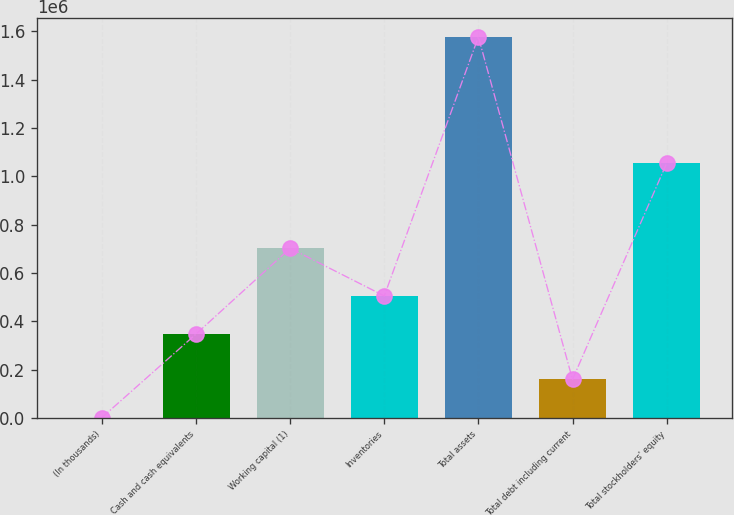<chart> <loc_0><loc_0><loc_500><loc_500><bar_chart><fcel>(In thousands)<fcel>Cash and cash equivalents<fcel>Working capital (1)<fcel>Inventories<fcel>Total assets<fcel>Total debt including current<fcel>Total stockholders' equity<nl><fcel>2013<fcel>347489<fcel>702181<fcel>504925<fcel>1.57637e+06<fcel>159449<fcel>1.05335e+06<nl></chart> 